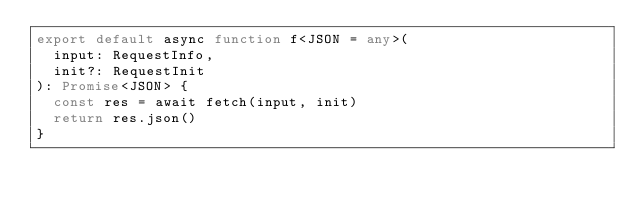Convert code to text. <code><loc_0><loc_0><loc_500><loc_500><_TypeScript_>export default async function f<JSON = any>(
  input: RequestInfo,
  init?: RequestInit
): Promise<JSON> {
  const res = await fetch(input, init)
  return res.json()
}
</code> 